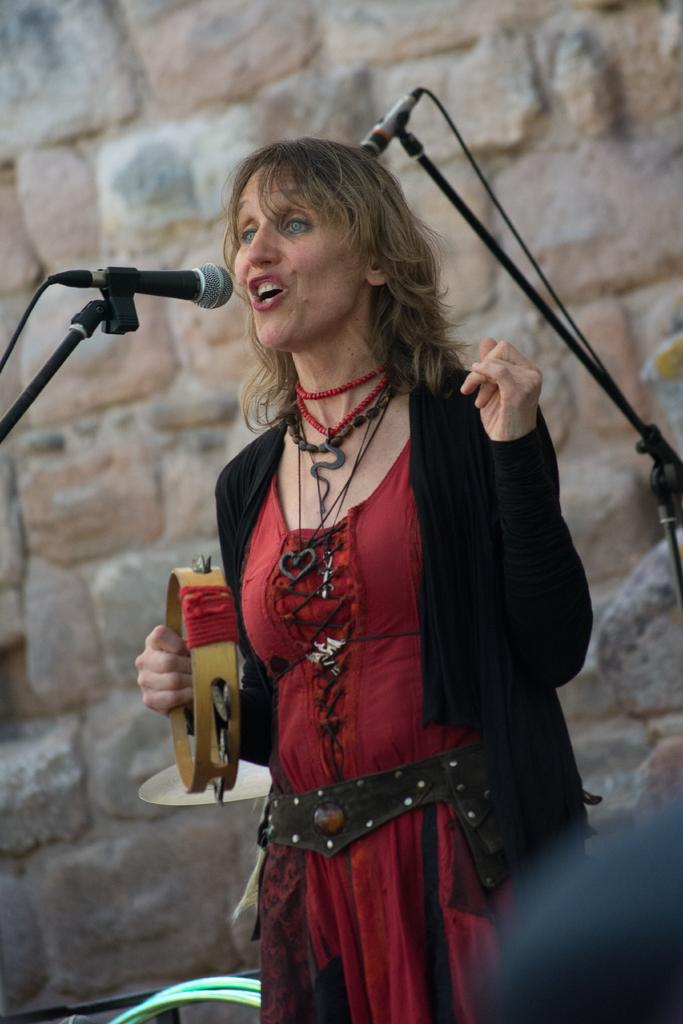What is the lady in the image doing? The lady is holding a musical instrument and singing. What is the lady holding in the image? The lady is holding a musical instrument. What can be seen in the background of the image? There is a wall visible in the image. Are there any animals present in the image? Yes, there are mice in the image. What type of necklace is the lady wearing in the image? There is no mention of a necklace in the provided facts, so we cannot determine if the lady is wearing one or what type it might be. --- Facts: 1. There is a car in the image. 2. The car is red. 3. The car has four wheels. 4. There is a road visible in the image. 5. The road is paved. Absurd Topics: birds, ocean, sand Conversation: What is the color of the car in the image? The car is red. How many wheels does the car have? The car has four wheels. What can be seen in the background of the image? There is a road visible in the image. What type of surface is the road made of? The road is paved. Reasoning: Let's think step by step in order to produce the conversation. We start by identifying the main subject in the image, which is the car. Then, we describe its color and the number of wheels it has. Next, we mention the road visible in the background and its paved surface. Absurd Question/Answer: Can you see any birds flying over the ocean in the image? There is no mention of birds, an ocean, or sand in the provided facts, so we cannot determine if any of these elements are present in the image. 